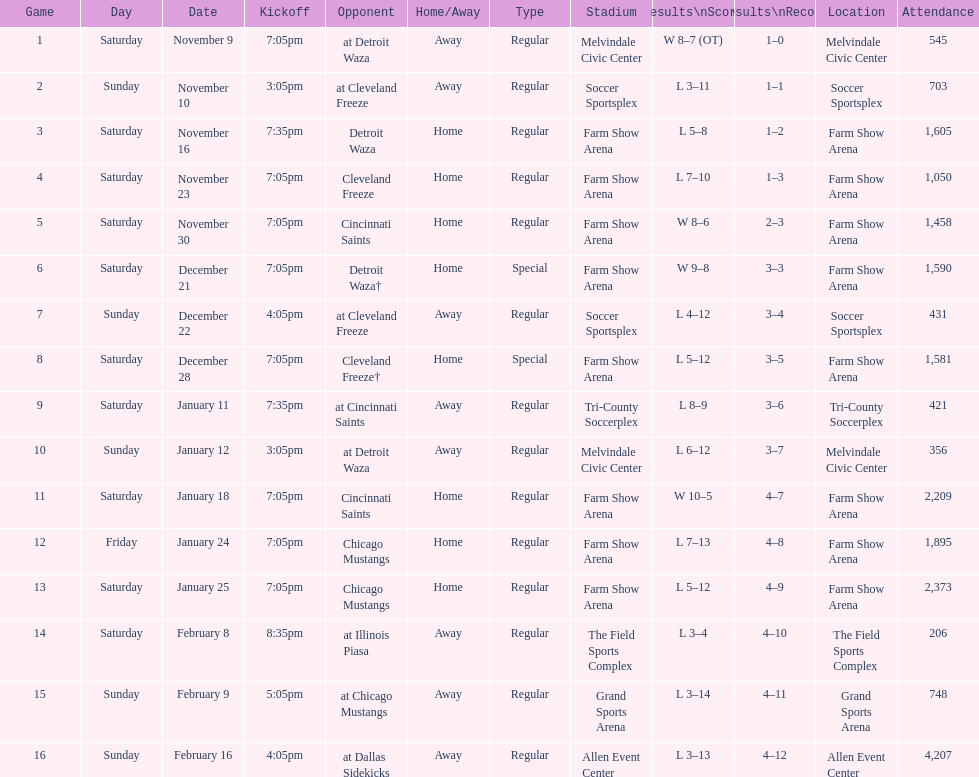What was the location before tri-county soccerplex? Farm Show Arena. 